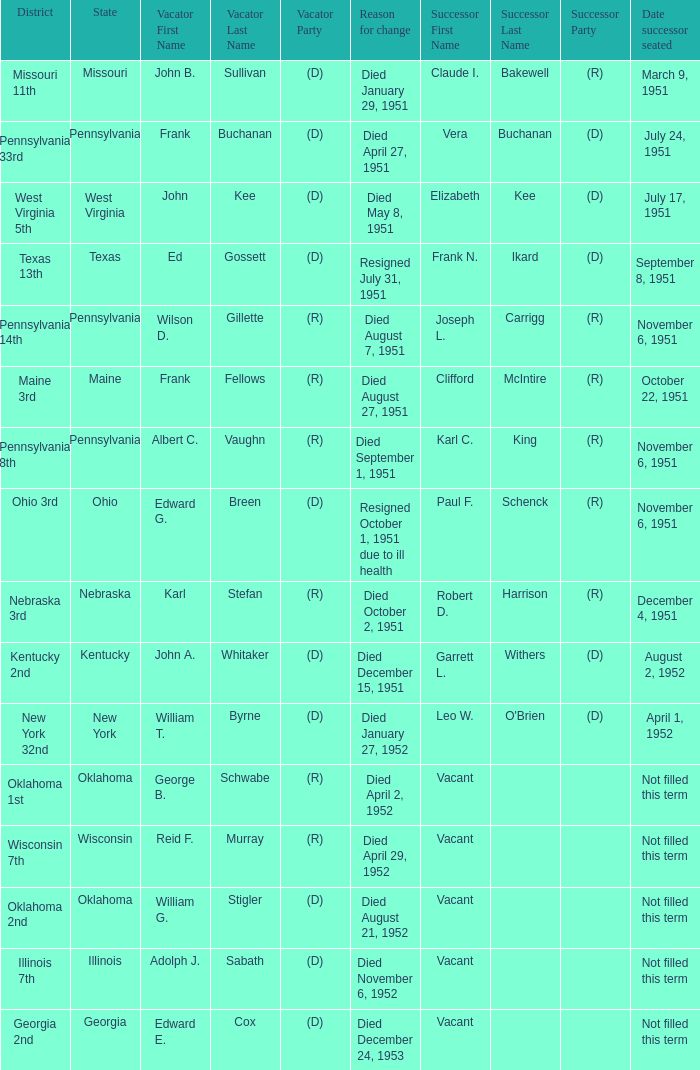How many vacators were in the Pennsylvania 33rd district? 1.0. Help me parse the entirety of this table. {'header': ['District', 'State', 'Vacator First Name', 'Vacator Last Name', 'Vacator Party', 'Reason for change', 'Successor First Name', 'Successor Last Name', 'Successor Party', 'Date successor seated'], 'rows': [['Missouri 11th', 'Missouri', 'John B.', 'Sullivan', '(D)', 'Died January 29, 1951', 'Claude I.', 'Bakewell', '(R)', 'March 9, 1951'], ['Pennsylvania 33rd', 'Pennsylvania', 'Frank', 'Buchanan', '(D)', 'Died April 27, 1951', 'Vera', 'Buchanan', '(D)', 'July 24, 1951'], ['West Virginia 5th', 'West Virginia', 'John', 'Kee', '(D)', 'Died May 8, 1951', 'Elizabeth', 'Kee', '(D)', 'July 17, 1951'], ['Texas 13th', 'Texas', 'Ed', 'Gossett', '(D)', 'Resigned July 31, 1951', 'Frank N.', 'Ikard', '(D)', 'September 8, 1951'], ['Pennsylvania 14th', 'Pennsylvania', 'Wilson D.', 'Gillette', '(R)', 'Died August 7, 1951', 'Joseph L.', 'Carrigg', '(R)', 'November 6, 1951'], ['Maine 3rd', 'Maine', 'Frank', 'Fellows', '(R)', 'Died August 27, 1951', 'Clifford', 'McIntire', '(R)', 'October 22, 1951'], ['Pennsylvania 8th', 'Pennsylvania', 'Albert C.', 'Vaughn', '(R)', 'Died September 1, 1951', 'Karl C.', 'King', '(R)', 'November 6, 1951'], ['Ohio 3rd', 'Ohio', 'Edward G.', 'Breen', '(D)', 'Resigned October 1, 1951 due to ill health', 'Paul F.', 'Schenck', '(R)', 'November 6, 1951'], ['Nebraska 3rd', 'Nebraska', 'Karl', 'Stefan', '(R)', 'Died October 2, 1951', 'Robert D.', 'Harrison', '(R)', 'December 4, 1951'], ['Kentucky 2nd', 'Kentucky', 'John A.', 'Whitaker', '(D)', 'Died December 15, 1951', 'Garrett L.', 'Withers', '(D)', 'August 2, 1952'], ['New York 32nd', 'New York', 'William T.', 'Byrne', '(D)', 'Died January 27, 1952', 'Leo W.', "O'Brien", '(D)', 'April 1, 1952'], ['Oklahoma 1st', 'Oklahoma', 'George B.', 'Schwabe', '(R)', 'Died April 2, 1952', 'Vacant', '', '', 'Not filled this term'], ['Wisconsin 7th', 'Wisconsin', 'Reid F.', 'Murray', '(R)', 'Died April 29, 1952', 'Vacant', '', '', 'Not filled this term'], ['Oklahoma 2nd', 'Oklahoma', 'William G.', 'Stigler', '(D)', 'Died August 21, 1952', 'Vacant', '', '', 'Not filled this term'], ['Illinois 7th', 'Illinois', 'Adolph J.', 'Sabath', '(D)', 'Died November 6, 1952', 'Vacant', '', '', 'Not filled this term'], ['Georgia 2nd', 'Georgia', 'Edward E.', 'Cox', '(D)', 'Died December 24, 1953', 'Vacant', '', '', 'Not filled this term']]} 